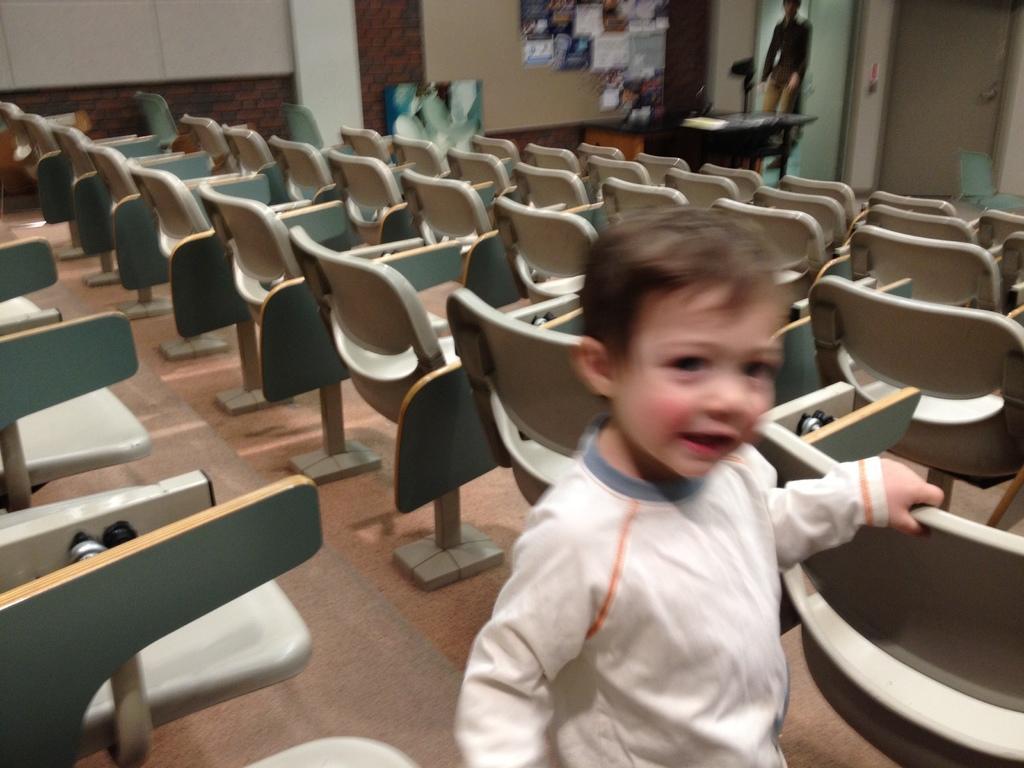Please provide a concise description of this image. In this picture we can see a boy who is standing floor. These are the chairs. And there is a table. Here we can see the wall. 